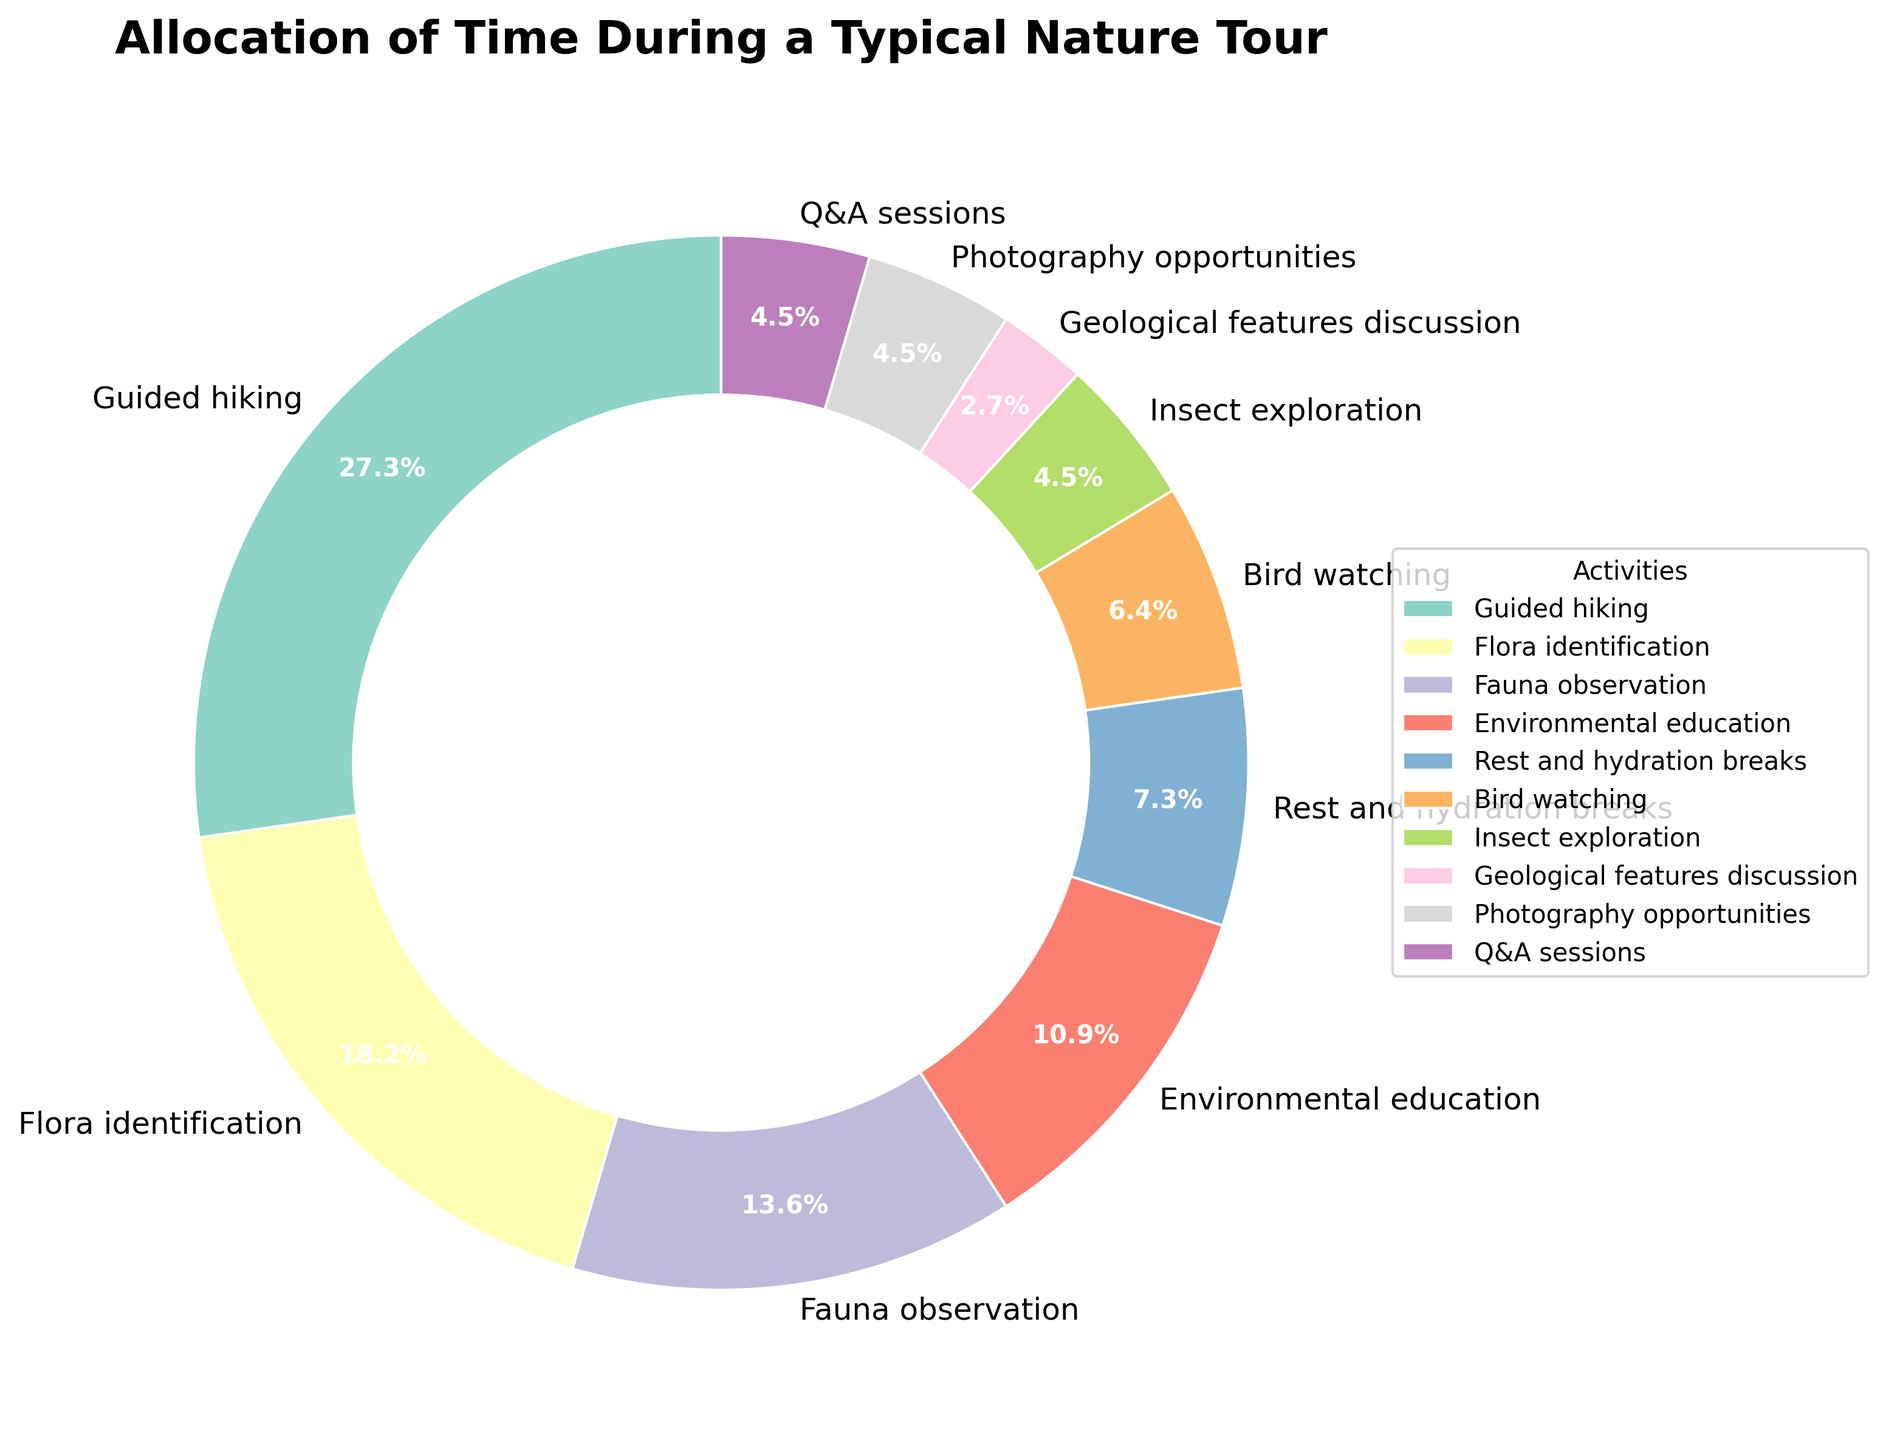What's the most time-consuming activity during the nature tour? The pie chart shows that the largest segment represents the activity “Guided hiking” with 30%.
Answer: Guided hiking Which two activities combined take up 35% of the time? The activities "Fauna observation" and "Flora identification" add up to 35% (15% + 20%).
Answer: Flora identification and Fauna observation What is the difference in percentage points between the time spent on Rest and hydration breaks and Bird watching? Rest and hydration breaks take 8% while Bird watching takes 7%. The difference is 8% - 7% = 1%.
Answer: 1% How much more time is allocated to Environmental education than Insect exploration? Environmental education takes up 12% and Insect exploration takes up 5%. The difference is 12% - 5% = 7%.
Answer: 7% What is the combined percentage of Photography opportunities, Q&A sessions, and Geological features discussion? The percentages for Photography opportunities, Q&A sessions, and Geological features discussion are 5%, 5%, and 3% respectively. Summing them up: 5% + 5% + 3% = 13%.
Answer: 13% Is the time allocated to Bird watching more or less than 10%? Bird watching is represented by a 7% slice in the pie chart, which is less than 10%.
Answer: Less If we combine the time spent on Flora identification and Bird watching, will it be more than the time spent on Guided hiking? Flora identification is 20% and Bird watching is 7%. Combined, they are 20% + 7% = 27%, which is less than Guided hiking's 30%.
Answer: No Which activity uses more time, Photography opportunities or Insect exploration? Photography opportunities and Insect exploration each take up 5%, so they use the same amount of time.
Answer: Same How much more time is allocated to Guided hiking in comparison to the total time spent on Geological features discussion and Rest and hydration breaks? Guided hiking is 30%. Geological features discussion and Rest and hydration breaks combined are 3% + 8% = 11%. The difference is 30% - 11% = 19%.
Answer: 19% What is the total percentage of the least three time-consuming activities? The three least time-consuming activities are Geological features discussion (3%), Bird watching (7%), and Insect exploration (5%). Summing them up: 3% + 7% + 5% = 15%.
Answer: 15% 